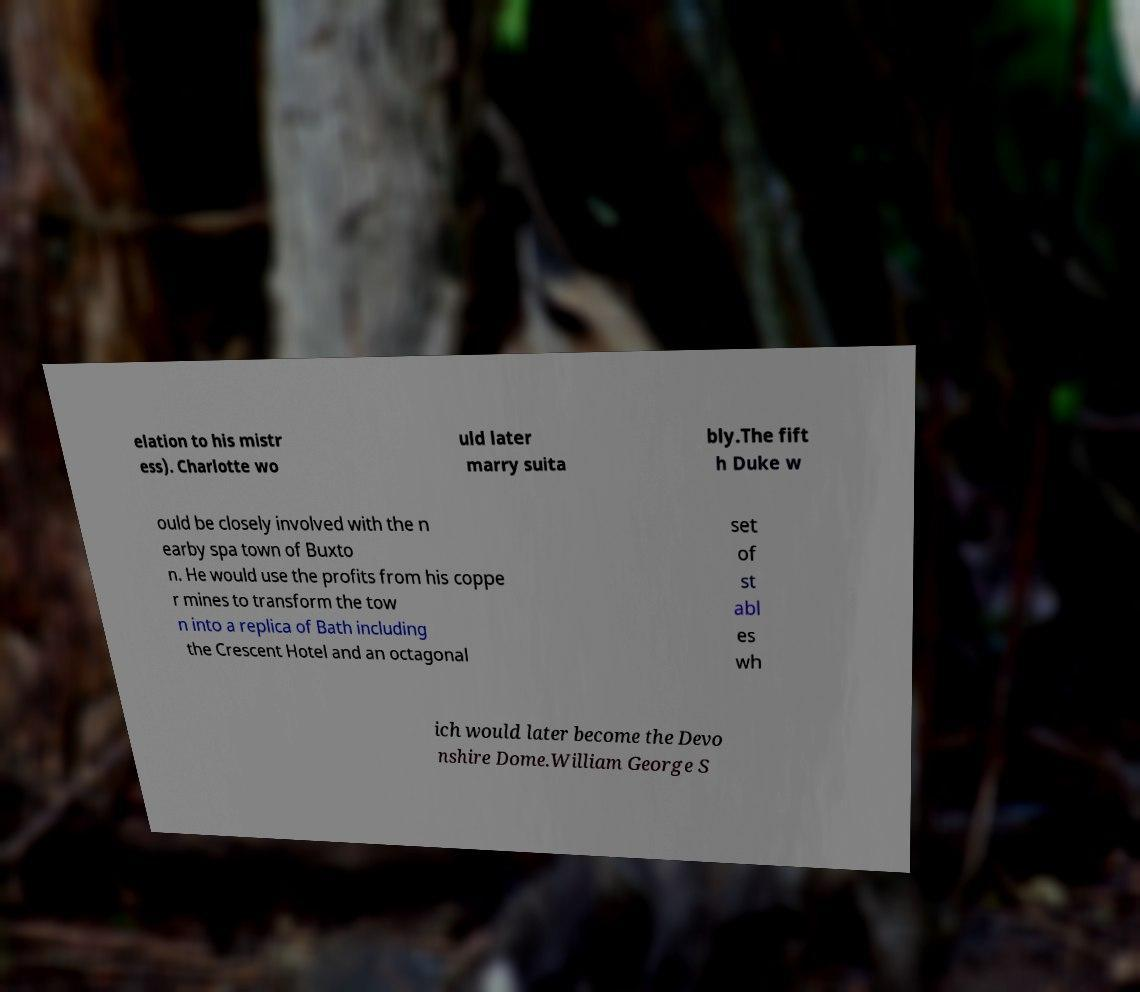Could you assist in decoding the text presented in this image and type it out clearly? elation to his mistr ess). Charlotte wo uld later marry suita bly.The fift h Duke w ould be closely involved with the n earby spa town of Buxto n. He would use the profits from his coppe r mines to transform the tow n into a replica of Bath including the Crescent Hotel and an octagonal set of st abl es wh ich would later become the Devo nshire Dome.William George S 